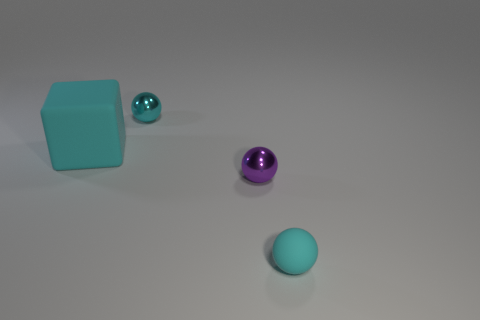Add 1 big matte cubes. How many objects exist? 5 Subtract all purple spheres. How many spheres are left? 2 Subtract all cyan metallic spheres. How many spheres are left? 2 Subtract all blocks. How many objects are left? 3 Subtract all brown cylinders. Subtract all purple shiny spheres. How many objects are left? 3 Add 2 large cyan blocks. How many large cyan blocks are left? 3 Add 1 big matte objects. How many big matte objects exist? 2 Subtract 0 yellow balls. How many objects are left? 4 Subtract all gray spheres. Subtract all red cylinders. How many spheres are left? 3 Subtract all blue balls. How many blue cubes are left? 0 